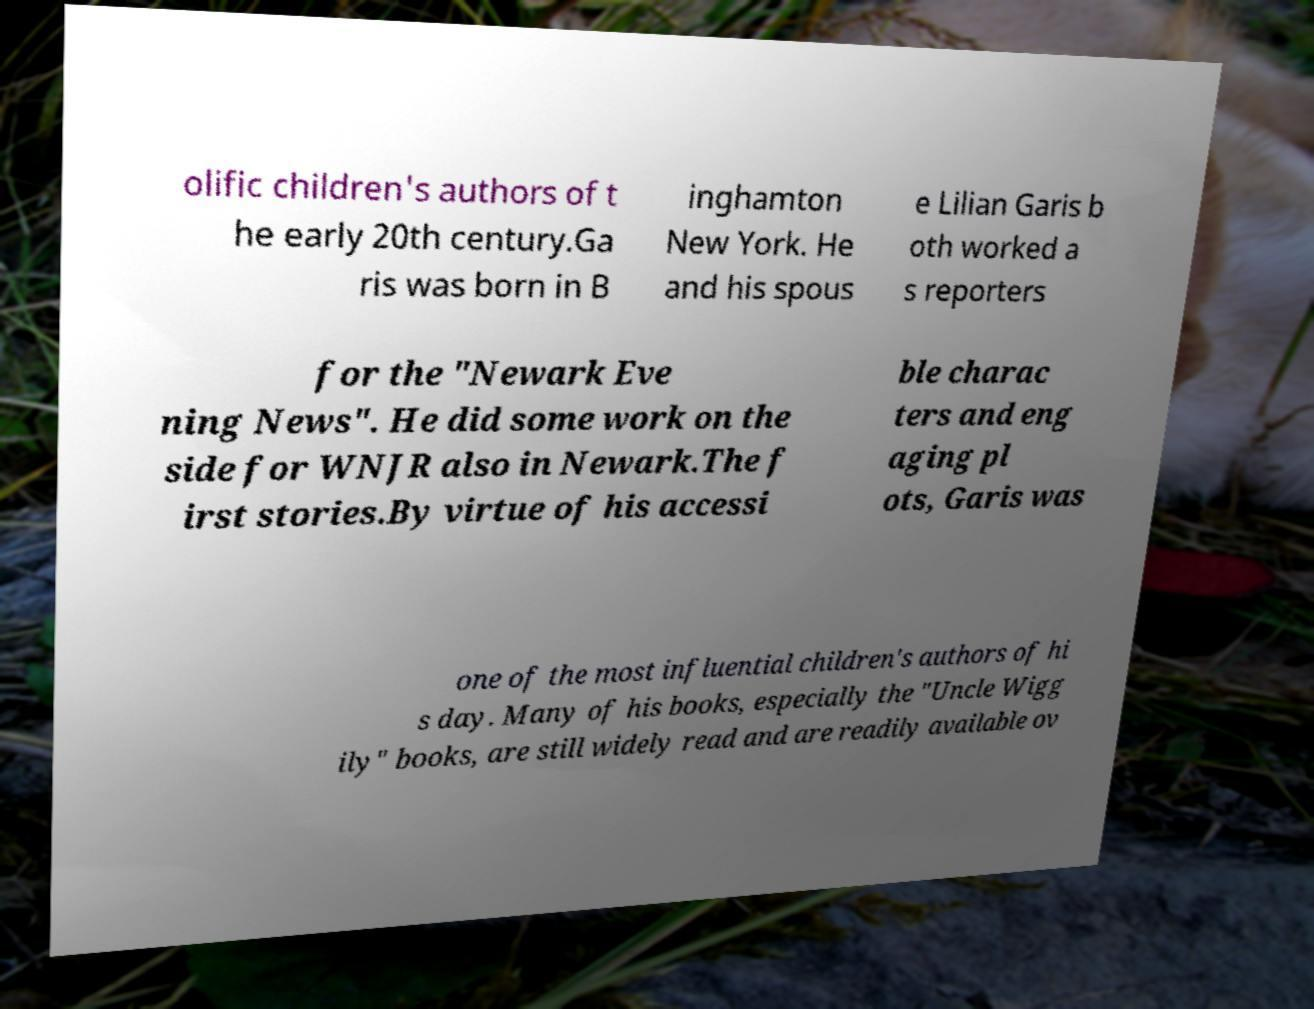What messages or text are displayed in this image? I need them in a readable, typed format. olific children's authors of t he early 20th century.Ga ris was born in B inghamton New York. He and his spous e Lilian Garis b oth worked a s reporters for the "Newark Eve ning News". He did some work on the side for WNJR also in Newark.The f irst stories.By virtue of his accessi ble charac ters and eng aging pl ots, Garis was one of the most influential children's authors of hi s day. Many of his books, especially the "Uncle Wigg ily" books, are still widely read and are readily available ov 